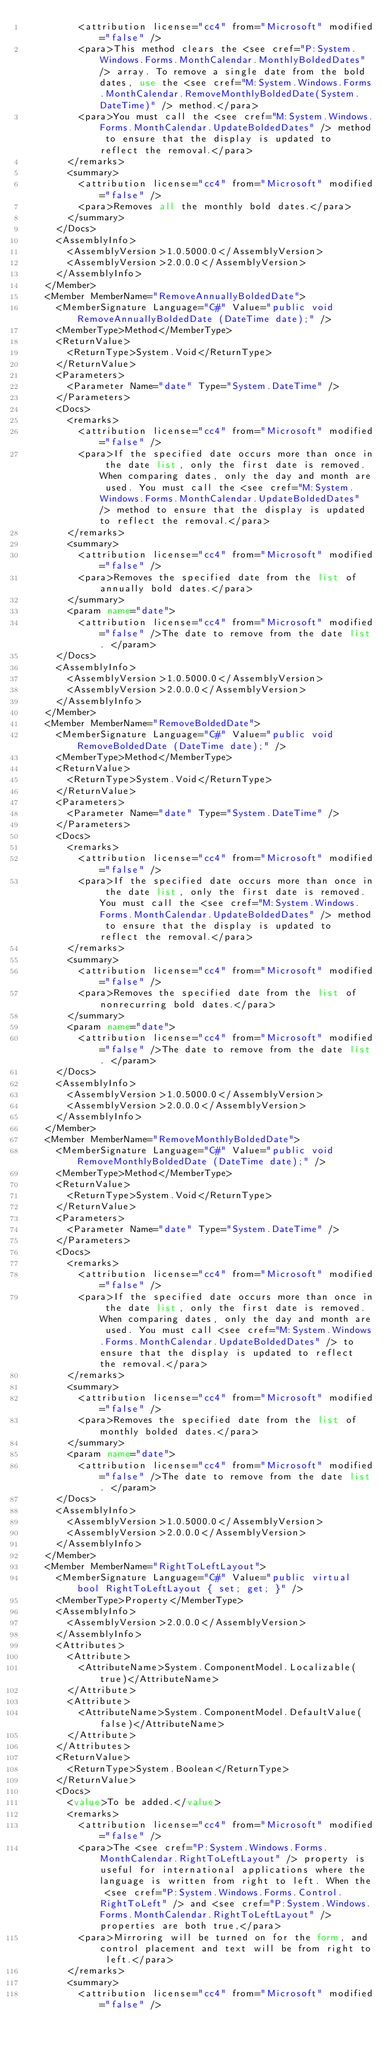<code> <loc_0><loc_0><loc_500><loc_500><_XML_>          <attribution license="cc4" from="Microsoft" modified="false" />
          <para>This method clears the <see cref="P:System.Windows.Forms.MonthCalendar.MonthlyBoldedDates" /> array. To remove a single date from the bold dates, use the <see cref="M:System.Windows.Forms.MonthCalendar.RemoveMonthlyBoldedDate(System.DateTime)" /> method.</para>
          <para>You must call the <see cref="M:System.Windows.Forms.MonthCalendar.UpdateBoldedDates" /> method to ensure that the display is updated to reflect the removal.</para>
        </remarks>
        <summary>
          <attribution license="cc4" from="Microsoft" modified="false" />
          <para>Removes all the monthly bold dates.</para>
        </summary>
      </Docs>
      <AssemblyInfo>
        <AssemblyVersion>1.0.5000.0</AssemblyVersion>
        <AssemblyVersion>2.0.0.0</AssemblyVersion>
      </AssemblyInfo>
    </Member>
    <Member MemberName="RemoveAnnuallyBoldedDate">
      <MemberSignature Language="C#" Value="public void RemoveAnnuallyBoldedDate (DateTime date);" />
      <MemberType>Method</MemberType>
      <ReturnValue>
        <ReturnType>System.Void</ReturnType>
      </ReturnValue>
      <Parameters>
        <Parameter Name="date" Type="System.DateTime" />
      </Parameters>
      <Docs>
        <remarks>
          <attribution license="cc4" from="Microsoft" modified="false" />
          <para>If the specified date occurs more than once in the date list, only the first date is removed. When comparing dates, only the day and month are used. You must call the <see cref="M:System.Windows.Forms.MonthCalendar.UpdateBoldedDates" /> method to ensure that the display is updated to reflect the removal.</para>
        </remarks>
        <summary>
          <attribution license="cc4" from="Microsoft" modified="false" />
          <para>Removes the specified date from the list of annually bold dates.</para>
        </summary>
        <param name="date">
          <attribution license="cc4" from="Microsoft" modified="false" />The date to remove from the date list. </param>
      </Docs>
      <AssemblyInfo>
        <AssemblyVersion>1.0.5000.0</AssemblyVersion>
        <AssemblyVersion>2.0.0.0</AssemblyVersion>
      </AssemblyInfo>
    </Member>
    <Member MemberName="RemoveBoldedDate">
      <MemberSignature Language="C#" Value="public void RemoveBoldedDate (DateTime date);" />
      <MemberType>Method</MemberType>
      <ReturnValue>
        <ReturnType>System.Void</ReturnType>
      </ReturnValue>
      <Parameters>
        <Parameter Name="date" Type="System.DateTime" />
      </Parameters>
      <Docs>
        <remarks>
          <attribution license="cc4" from="Microsoft" modified="false" />
          <para>If the specified date occurs more than once in the date list, only the first date is removed. You must call the <see cref="M:System.Windows.Forms.MonthCalendar.UpdateBoldedDates" /> method to ensure that the display is updated to reflect the removal.</para>
        </remarks>
        <summary>
          <attribution license="cc4" from="Microsoft" modified="false" />
          <para>Removes the specified date from the list of nonrecurring bold dates.</para>
        </summary>
        <param name="date">
          <attribution license="cc4" from="Microsoft" modified="false" />The date to remove from the date list. </param>
      </Docs>
      <AssemblyInfo>
        <AssemblyVersion>1.0.5000.0</AssemblyVersion>
        <AssemblyVersion>2.0.0.0</AssemblyVersion>
      </AssemblyInfo>
    </Member>
    <Member MemberName="RemoveMonthlyBoldedDate">
      <MemberSignature Language="C#" Value="public void RemoveMonthlyBoldedDate (DateTime date);" />
      <MemberType>Method</MemberType>
      <ReturnValue>
        <ReturnType>System.Void</ReturnType>
      </ReturnValue>
      <Parameters>
        <Parameter Name="date" Type="System.DateTime" />
      </Parameters>
      <Docs>
        <remarks>
          <attribution license="cc4" from="Microsoft" modified="false" />
          <para>If the specified date occurs more than once in the date list, only the first date is removed. When comparing dates, only the day and month are used. You must call <see cref="M:System.Windows.Forms.MonthCalendar.UpdateBoldedDates" /> to ensure that the display is updated to reflect the removal.</para>
        </remarks>
        <summary>
          <attribution license="cc4" from="Microsoft" modified="false" />
          <para>Removes the specified date from the list of monthly bolded dates.</para>
        </summary>
        <param name="date">
          <attribution license="cc4" from="Microsoft" modified="false" />The date to remove from the date list. </param>
      </Docs>
      <AssemblyInfo>
        <AssemblyVersion>1.0.5000.0</AssemblyVersion>
        <AssemblyVersion>2.0.0.0</AssemblyVersion>
      </AssemblyInfo>
    </Member>
    <Member MemberName="RightToLeftLayout">
      <MemberSignature Language="C#" Value="public virtual bool RightToLeftLayout { set; get; }" />
      <MemberType>Property</MemberType>
      <AssemblyInfo>
        <AssemblyVersion>2.0.0.0</AssemblyVersion>
      </AssemblyInfo>
      <Attributes>
        <Attribute>
          <AttributeName>System.ComponentModel.Localizable(true)</AttributeName>
        </Attribute>
        <Attribute>
          <AttributeName>System.ComponentModel.DefaultValue(false)</AttributeName>
        </Attribute>
      </Attributes>
      <ReturnValue>
        <ReturnType>System.Boolean</ReturnType>
      </ReturnValue>
      <Docs>
        <value>To be added.</value>
        <remarks>
          <attribution license="cc4" from="Microsoft" modified="false" />
          <para>The <see cref="P:System.Windows.Forms.MonthCalendar.RightToLeftLayout" /> property is useful for international applications where the language is written from right to left. When the <see cref="P:System.Windows.Forms.Control.RightToLeft" /> and <see cref="P:System.Windows.Forms.MonthCalendar.RightToLeftLayout" /> properties are both true,</para>
          <para>Mirroring will be turned on for the form, and control placement and text will be from right to left.</para>
        </remarks>
        <summary>
          <attribution license="cc4" from="Microsoft" modified="false" /></code> 